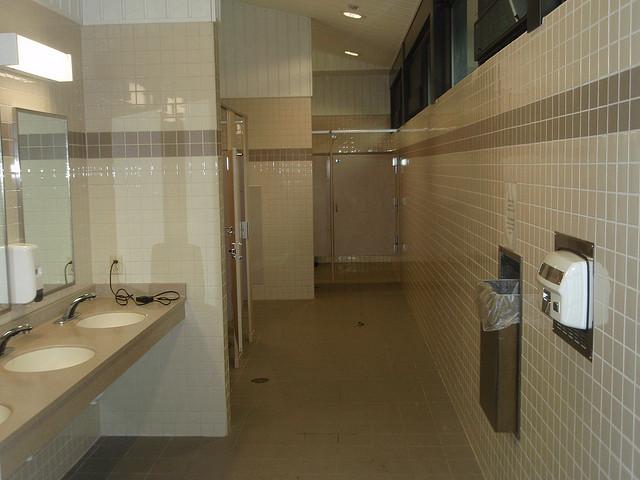What color is the mirror's frame?
Concise answer only. Silver. Is there a charger device plugged in?
Short answer required. Yes. What is normally done in this type of room?
Write a very short answer. Using restroom. Is there a ramp in the picture?
Short answer required. No. Do people dry their hands with paper towels in this room?
Concise answer only. No. 